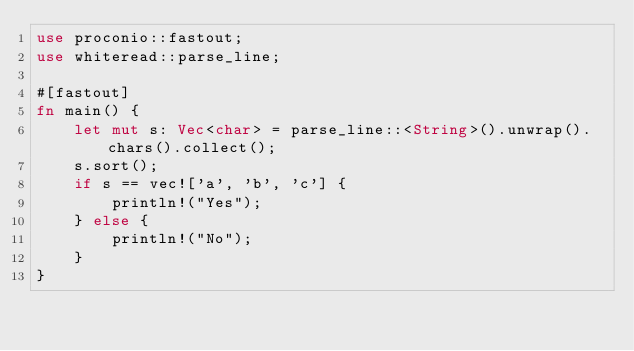Convert code to text. <code><loc_0><loc_0><loc_500><loc_500><_Rust_>use proconio::fastout;
use whiteread::parse_line;

#[fastout]
fn main() {
    let mut s: Vec<char> = parse_line::<String>().unwrap().chars().collect();
    s.sort();
    if s == vec!['a', 'b', 'c'] {
        println!("Yes");
    } else {
        println!("No");
    }
}
</code> 